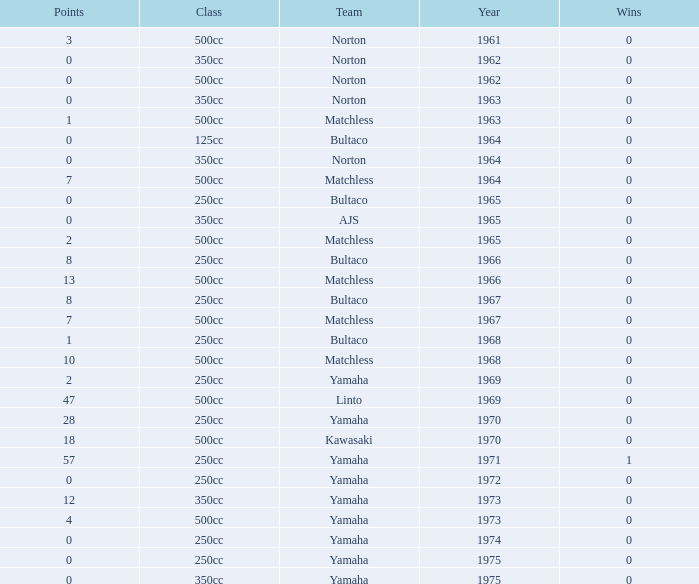What is the average wins in 250cc class for Bultaco with 8 points later than 1966? 0.0. 